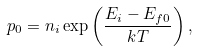<formula> <loc_0><loc_0><loc_500><loc_500>p _ { 0 } = n _ { i } \exp \left ( \frac { E _ { i } - E _ { f 0 } } { k T } \right ) ,</formula> 